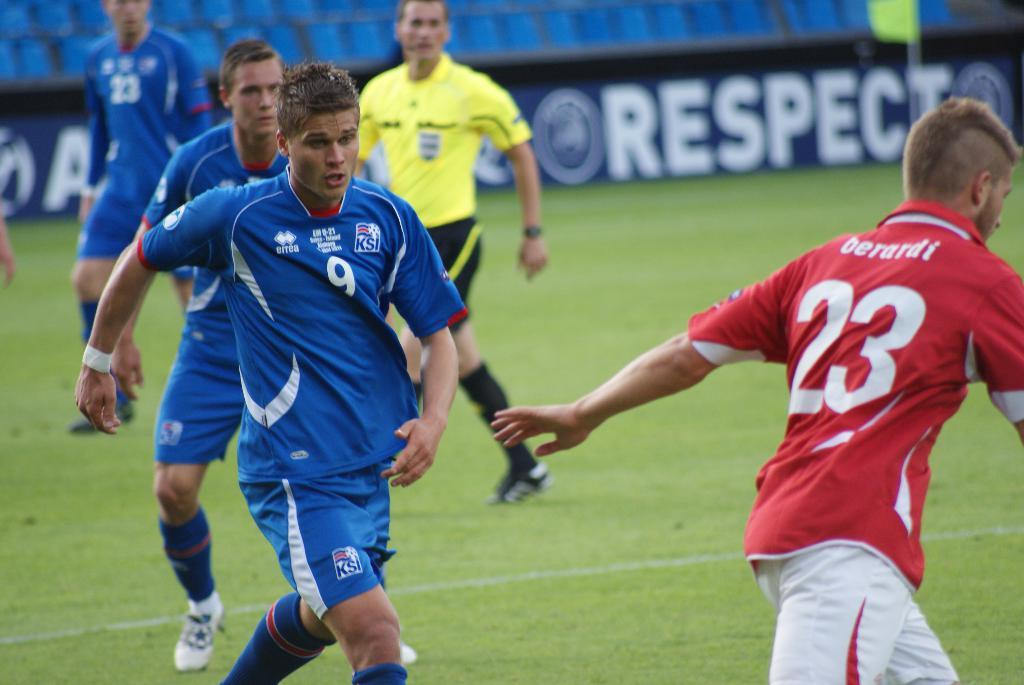<image>
Offer a succinct explanation of the picture presented. A game with players in red and blue uniform with the name berardi on the back. 